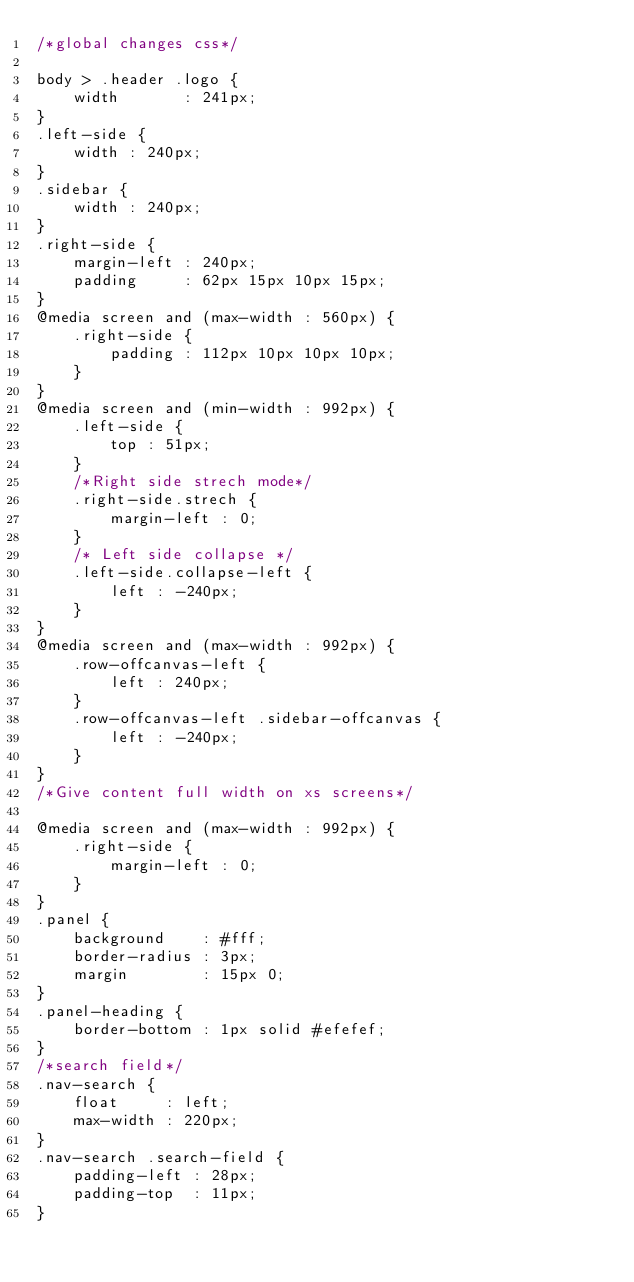<code> <loc_0><loc_0><loc_500><loc_500><_CSS_>/*global changes css*/

body > .header .logo {
    width       : 241px;
}
.left-side {
    width : 240px;
}
.sidebar {
    width : 240px;
}
.right-side {
    margin-left : 240px;
    padding     : 62px 15px 10px 15px;
}
@media screen and (max-width : 560px) {
    .right-side {
        padding : 112px 10px 10px 10px;
    }
}
@media screen and (min-width : 992px) {
    .left-side {
        top : 51px;
    }
    /*Right side strech mode*/
    .right-side.strech {
        margin-left : 0;
    }
    /* Left side collapse */
    .left-side.collapse-left {
        left : -240px;
    }
}
@media screen and (max-width : 992px) {
    .row-offcanvas-left {
        left : 240px;
    }
    .row-offcanvas-left .sidebar-offcanvas {
        left : -240px;
    }
}
/*Give content full width on xs screens*/

@media screen and (max-width : 992px) {
    .right-side {
        margin-left : 0;
    }
}
.panel {
    background    : #fff;
    border-radius : 3px;
    margin        : 15px 0;
}
.panel-heading {
    border-bottom : 1px solid #efefef;
}
/*search field*/
.nav-search {
    float     : left;
    max-width : 220px;
}
.nav-search .search-field {
    padding-left : 28px;
    padding-top  : 11px;
}</code> 